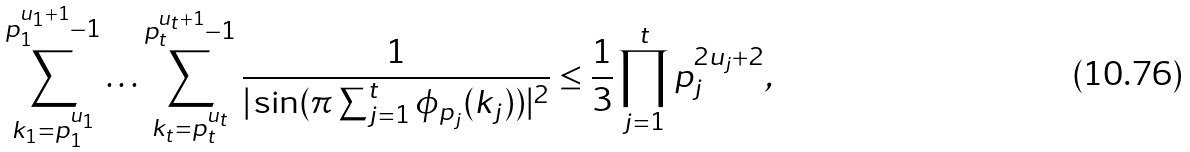Convert formula to latex. <formula><loc_0><loc_0><loc_500><loc_500>\sum _ { k _ { 1 } = p _ { 1 } ^ { u _ { 1 } } } ^ { p _ { 1 } ^ { u _ { 1 } + 1 } - 1 } \dots \sum _ { k _ { t } = p _ { t } ^ { u _ { t } } } ^ { p _ { t } ^ { u _ { t } + 1 } - 1 } \frac { 1 } { | \sin ( \pi \sum _ { j = 1 } ^ { t } \phi _ { p _ { j } } ( k _ { j } ) ) | ^ { 2 } } \leq \frac { 1 } { 3 } \prod _ { j = 1 } ^ { t } p _ { j } ^ { 2 u _ { j } + 2 } ,</formula> 